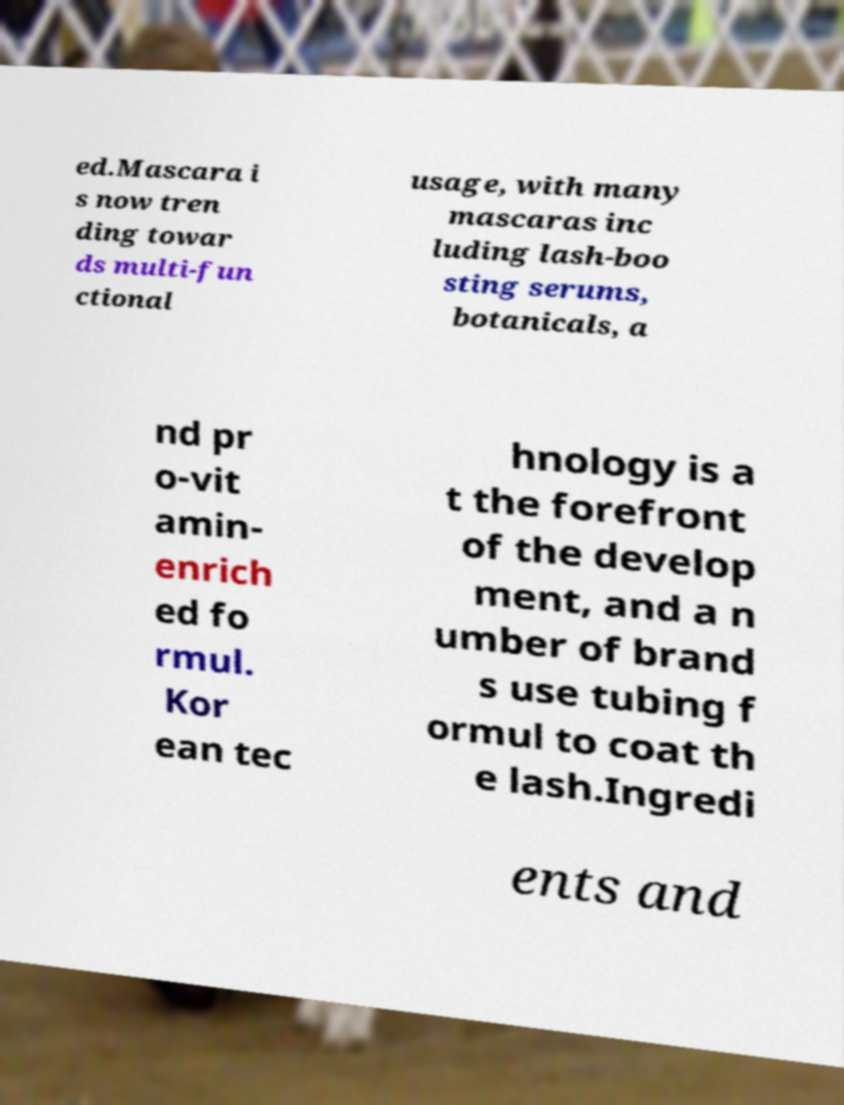Please identify and transcribe the text found in this image. ed.Mascara i s now tren ding towar ds multi-fun ctional usage, with many mascaras inc luding lash-boo sting serums, botanicals, a nd pr o-vit amin- enrich ed fo rmul. Kor ean tec hnology is a t the forefront of the develop ment, and a n umber of brand s use tubing f ormul to coat th e lash.Ingredi ents and 